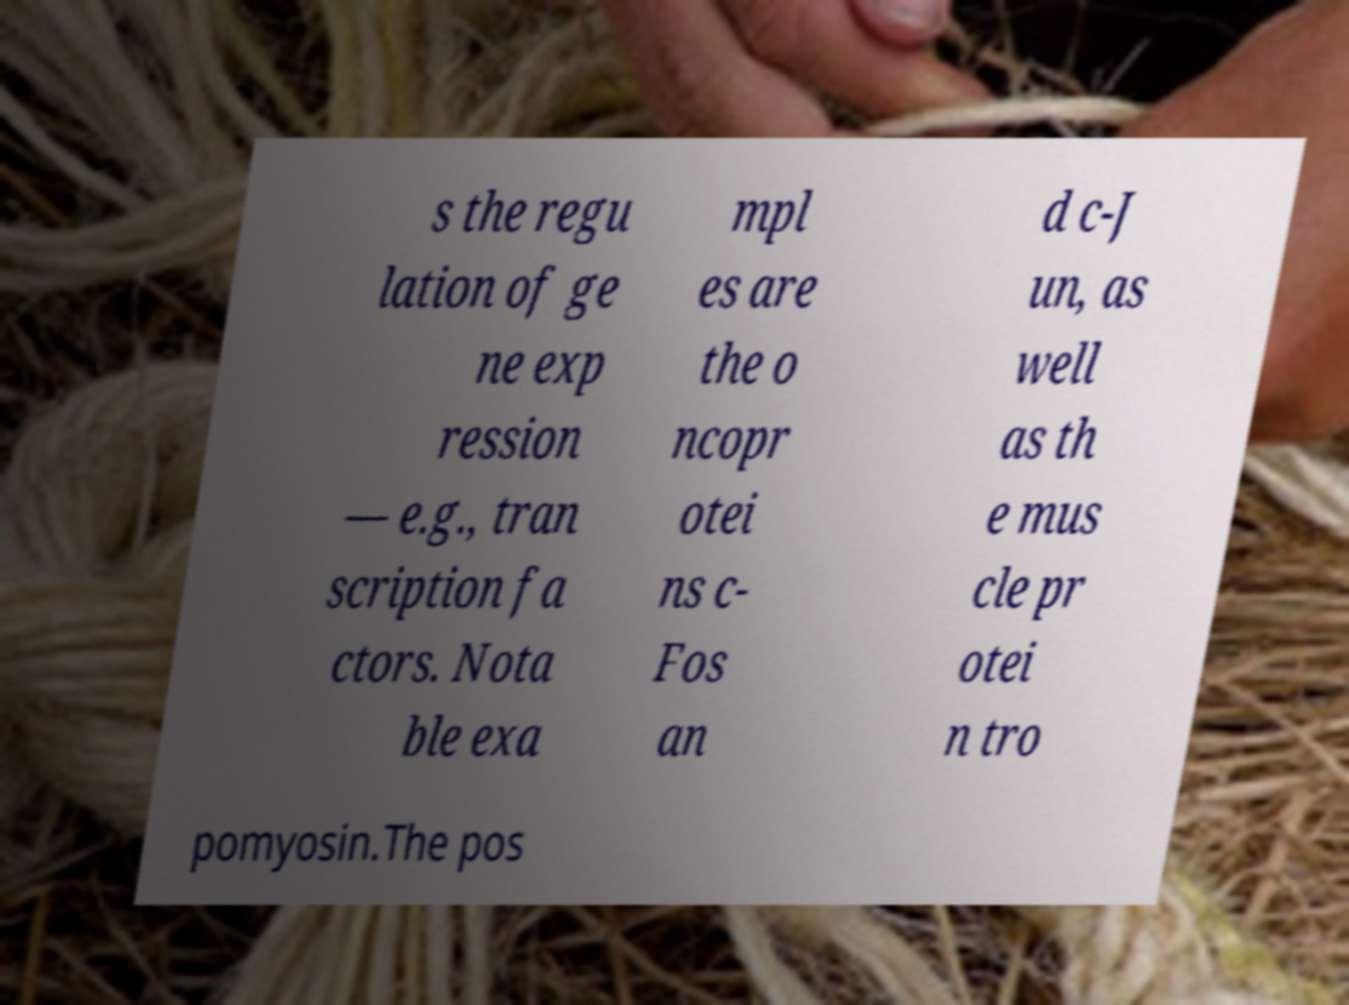Can you read and provide the text displayed in the image?This photo seems to have some interesting text. Can you extract and type it out for me? s the regu lation of ge ne exp ression — e.g., tran scription fa ctors. Nota ble exa mpl es are the o ncopr otei ns c- Fos an d c-J un, as well as th e mus cle pr otei n tro pomyosin.The pos 